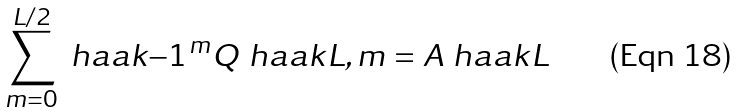<formula> <loc_0><loc_0><loc_500><loc_500>\sum _ { m = 0 } ^ { L / 2 } \ h a a k { - 1 } ^ { m } Q \ h a a k { L , m } = A \ h a a k { L }</formula> 